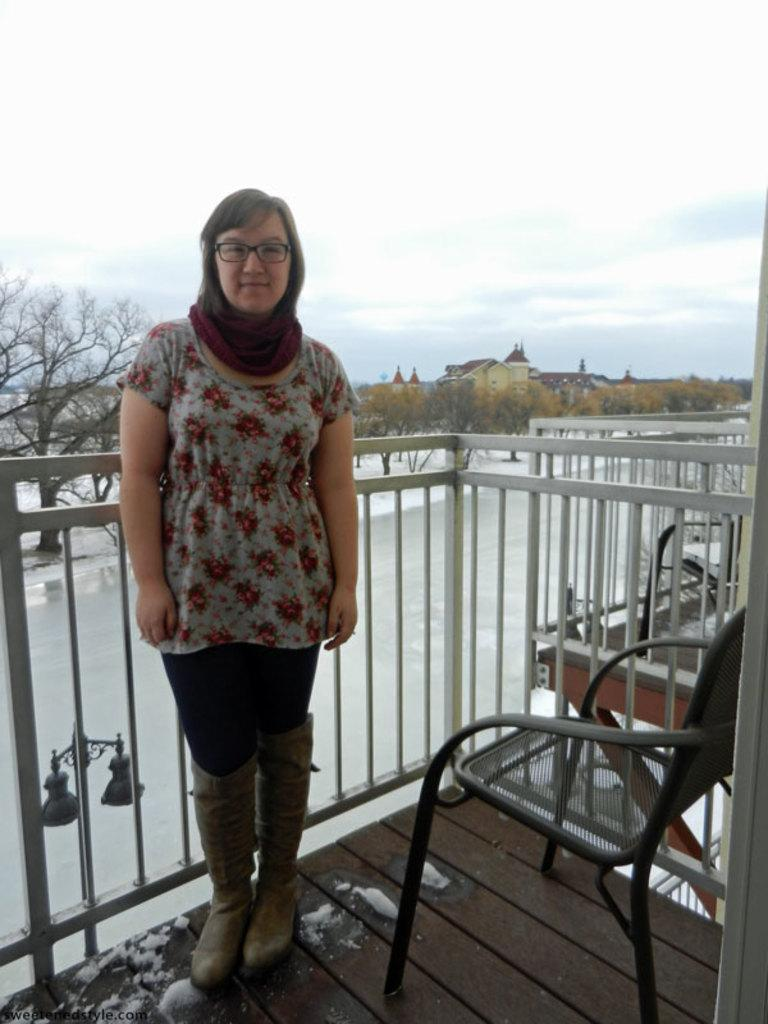Who is present in the image? There is a woman in the image. Where is the woman standing? The woman is standing in a veranda. What can be seen behind the woman? There is a tree behind the woman. What is visible in the background of the image? The sky is visible in the image. What is on the right side of the image? There is a chair on the right side of the image. What is the woman wearing? The woman is wearing a gold dress. What type of brain can be seen in the image? There is no brain present in the image; it features a woman standing in a veranda. Is there a rainstorm occurring in the image? There is no indication of a rainstorm in the image; the sky is visible, but it does not appear to be stormy. 